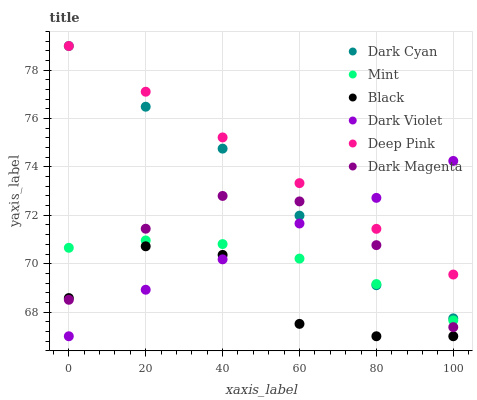Does Black have the minimum area under the curve?
Answer yes or no. Yes. Does Deep Pink have the maximum area under the curve?
Answer yes or no. Yes. Does Dark Magenta have the minimum area under the curve?
Answer yes or no. No. Does Dark Magenta have the maximum area under the curve?
Answer yes or no. No. Is Deep Pink the smoothest?
Answer yes or no. Yes. Is Black the roughest?
Answer yes or no. Yes. Is Dark Magenta the smoothest?
Answer yes or no. No. Is Dark Magenta the roughest?
Answer yes or no. No. Does Dark Violet have the lowest value?
Answer yes or no. Yes. Does Dark Magenta have the lowest value?
Answer yes or no. No. Does Dark Cyan have the highest value?
Answer yes or no. Yes. Does Dark Magenta have the highest value?
Answer yes or no. No. Is Black less than Deep Pink?
Answer yes or no. Yes. Is Deep Pink greater than Dark Magenta?
Answer yes or no. Yes. Does Mint intersect Dark Cyan?
Answer yes or no. Yes. Is Mint less than Dark Cyan?
Answer yes or no. No. Is Mint greater than Dark Cyan?
Answer yes or no. No. Does Black intersect Deep Pink?
Answer yes or no. No. 